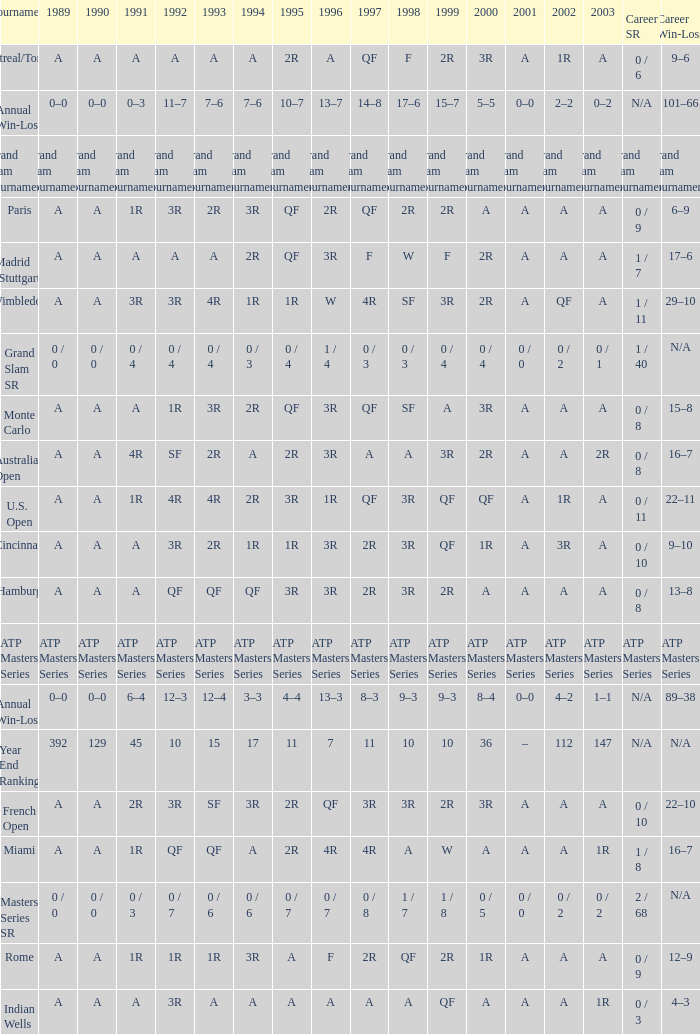What was the value in 1995 for A in 2000 at the Indian Wells tournament? A. 